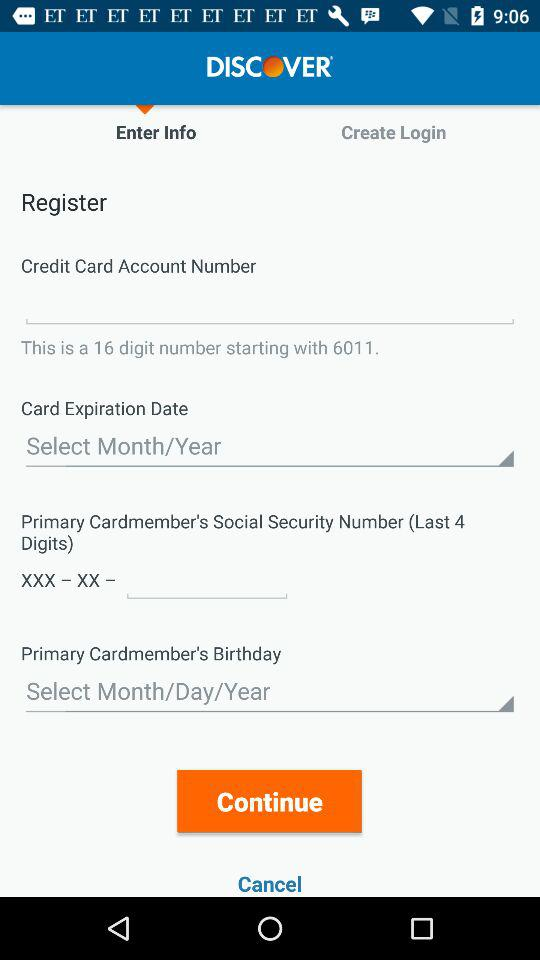What is the number of digits on the credit card? The number of digits is 16. 